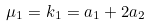<formula> <loc_0><loc_0><loc_500><loc_500>\mu _ { 1 } = k _ { 1 } = a _ { 1 } + 2 a _ { 2 }</formula> 